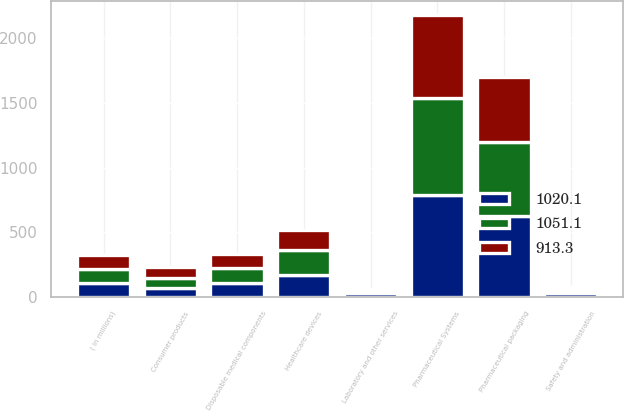Convert chart. <chart><loc_0><loc_0><loc_500><loc_500><stacked_bar_chart><ecel><fcel>( in millions)<fcel>Pharmaceutical packaging<fcel>Disposable medical components<fcel>Safety and administration<fcel>Laboratory and other services<fcel>Pharmaceutical Systems<fcel>Healthcare devices<fcel>Consumer products<nl><fcel>1020.1<fcel>109.2<fcel>622.8<fcel>107.2<fcel>33.1<fcel>29<fcel>792.1<fcel>171.7<fcel>74.1<nl><fcel>1051.1<fcel>109.2<fcel>577.8<fcel>120.4<fcel>25.5<fcel>18.1<fcel>741.8<fcel>188.8<fcel>73.3<nl><fcel>913.3<fcel>109.2<fcel>495.8<fcel>109.2<fcel>21<fcel>18.1<fcel>644.1<fcel>155.6<fcel>84.4<nl></chart> 